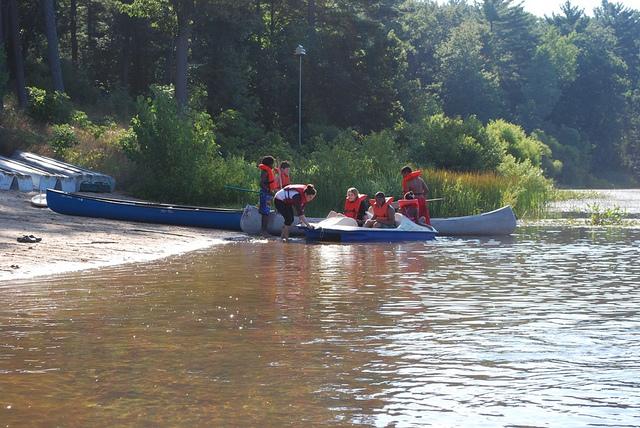Is the water very deep?
Keep it brief. No. What color are the lifejackets being worn?
Answer briefly. Orange. What is around the neck of the people?
Be succinct. Life vests. 